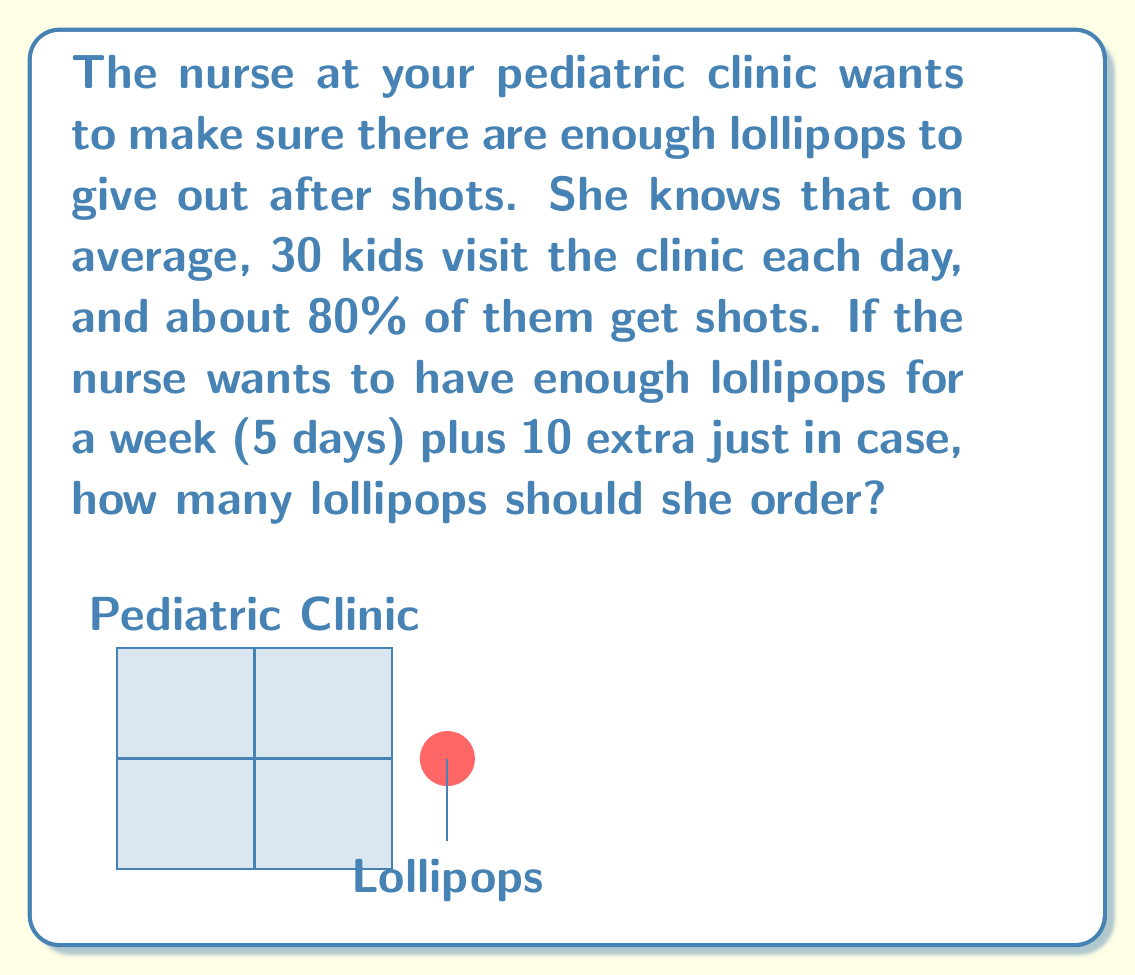Can you solve this math problem? Let's break this down step-by-step:

1) First, we need to find out how many kids get shots each day:
   $30 \text{ kids} \times 80\% = 30 \times 0.8 = 24 \text{ kids}$

2) Now, we know that 24 kids need lollipops each day.

3) For a week (5 days), we multiply this by 5:
   $24 \text{ kids per day} \times 5 \text{ days} = 120 \text{ lollipops}$

4) The nurse wants 10 extra lollipops, so we add this to our total:
   $120 \text{ lollipops} + 10 \text{ extra} = 130 \text{ lollipops}$

Therefore, the nurse should order 130 lollipops to have enough for a week plus some extra.
Answer: 130 lollipops 